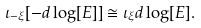Convert formula to latex. <formula><loc_0><loc_0><loc_500><loc_500>\iota _ { - \xi } [ - d \log [ E ] ] \cong \iota _ { \xi } d \log [ E ] .</formula> 